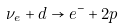Convert formula to latex. <formula><loc_0><loc_0><loc_500><loc_500>\nu _ { e } + d \rightarrow e ^ { - } + 2 p</formula> 